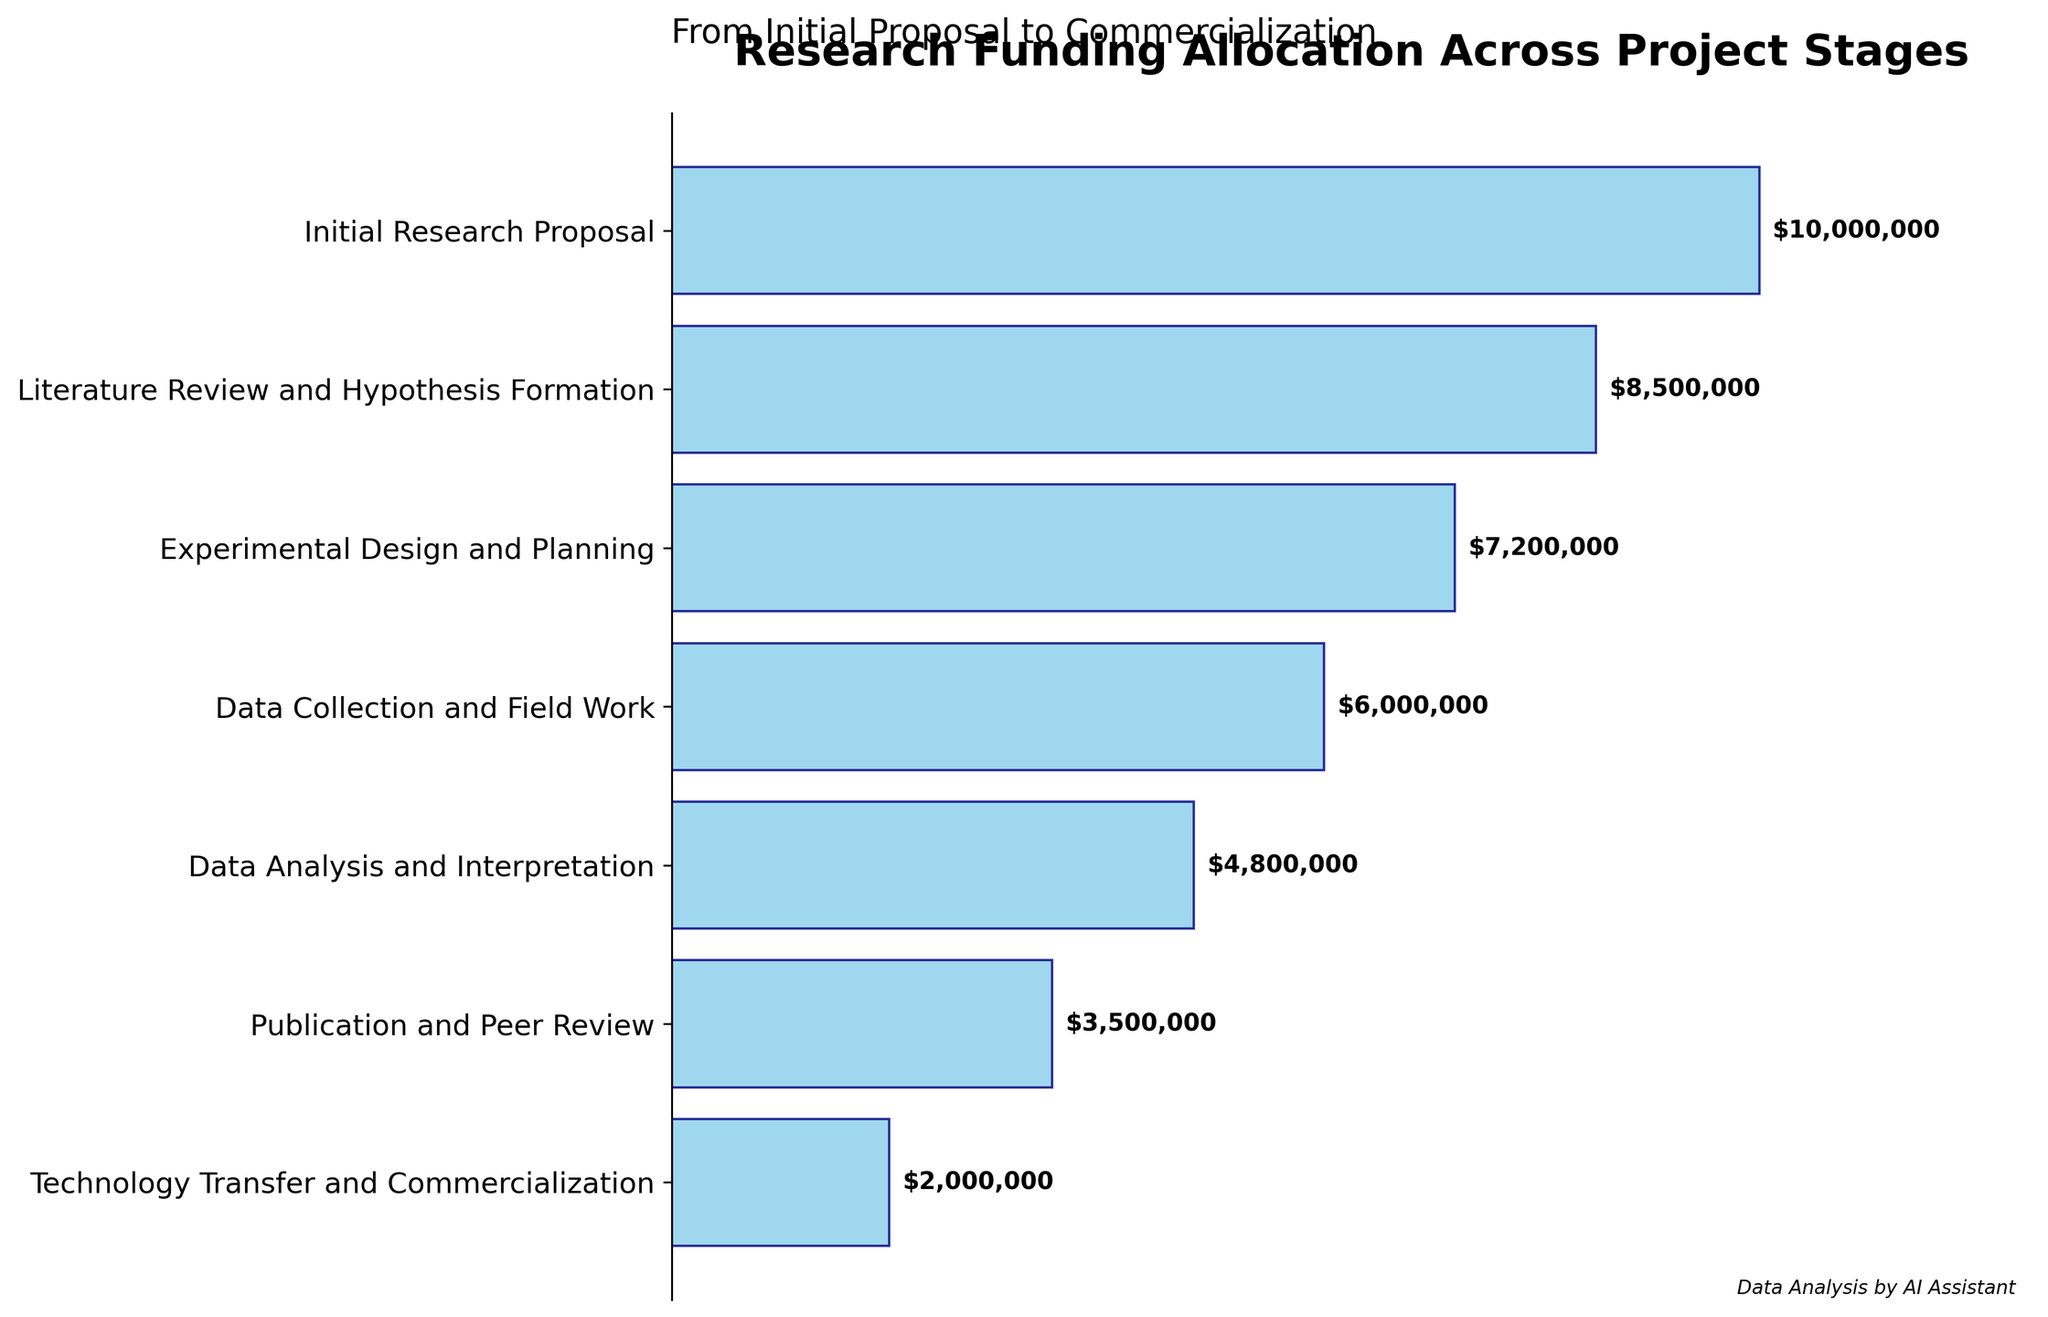What is the funding amount for the "Initial Research Proposal" stage? The funding amount is provided directly on the plot for each stage. Locate the stage "Initial Research Proposal" and read the funding amount next to it.
Answer: $10,000,000 What stage receives the least funding? Check the funding amounts displayed next to each stage and identify the smallest one.
Answer: Technology Transfer and Commercialization What is the total amount of funding allocated across all the stages? Sum the funding amounts for all stages listed in the plot: $10,000,000, $8,500,000, $7,200,000, $6,000,000, $4,800,000, $3,500,000, and $2,000,000. Total: $10,000,000 + $8,500,000 + $7,200,000 + $6,000,000 + $4,800,000 + $3,500,000 + $2,000,000.
Answer: $42,000,000 Which stage has a funding amount that is closest to the average funding across all stages? First, calculate the average funding by dividing the total funding amount by the number of stages. The total funding is $42,000,000, and there are 7 stages, so the average is $42,000,000 / 7 = $6,000,000. Then, compare each stage’s funding to this average and find the closest value.
Answer: Data Collection and Field Work What is the total funding allocated from "Experimental Design and Planning" to "Publication and Peer Review"? Sum the funding amounts for the stages from "Experimental Design and Planning" to "Publication and Peer Review": $7,200,000 (Experimental Design and Planning) + $6,000,000 (Data Collection and Field Work) + $4,800,000 (Data Analysis and Interpretation) + $3,500,000 (Publication and Peer Review). Total: $7,200,000 + $6,000,000 + $4,800,000 + $3,500,000.
Answer: $21,500,000 How much more funding is allocated to "Experimental Design and Planning" compared to "Publication and Peer Review"? Subtract the funding amount for "Publication and Peer Review" from the funding amount for "Experimental Design and Planning": $7,200,000 (Experimental Design and Planning) - $3,500,000 (Publication and Peer Review).
Answer: $3,700,000 Which stage has seen the greatest relative decrease in funding compared to the previous stage? Calculate the percentage decrease in funding between each consecutive pair of stages using the formula [(Previous Stage Funding - Current Stage Funding) / Previous Stage Funding] * 100. Compare the results to find the greatest decrease.
Answer: Technology Transfer and Commercialization What percentage of the total funding is allocated to the "Data Analysis and Interpretation" stage? Divide the funding amount for "Data Analysis and Interpretation" by the total funding amount and multiply by 100 to obtain the percentage: ($4,800,000 / $42,000,000) * 100.
Answer: 11.43% What's the median funding amount across all stages? Order the funding amounts from smallest to largest and find the middle value. The ordered funding amounts are: $2,000,000, $3,500,000, $4,800,000, $6,000,000, $7,200,000, $8,500,000, $10,000,000. The middle (median) value is the fourth value.
Answer: $6,000,000 